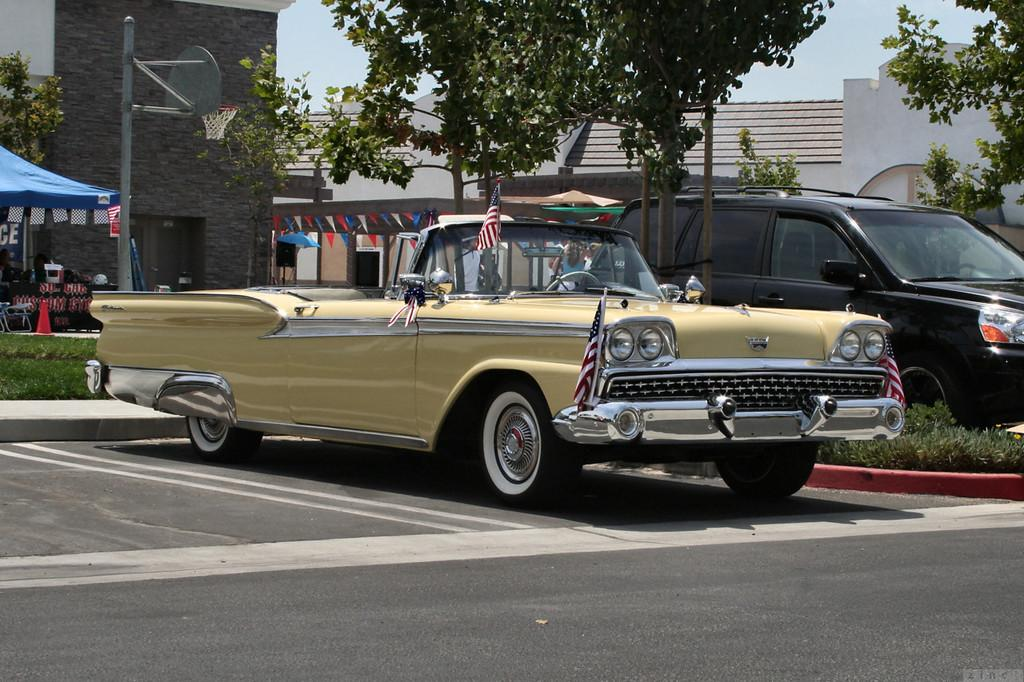How many cars are visible on the road in the image? There are two cars on the road in the image. What can be seen in the background of the image? In the background, there are trees, buildings, grass, flags, the sky, and other objects on the ground. What type of vegetation is present in the background? Grass is present in the background. What else is visible in the sky besides the sky itself? There are flags visible in the sky. Is there a cannon visible in the image? There is no cannon present in the image. 